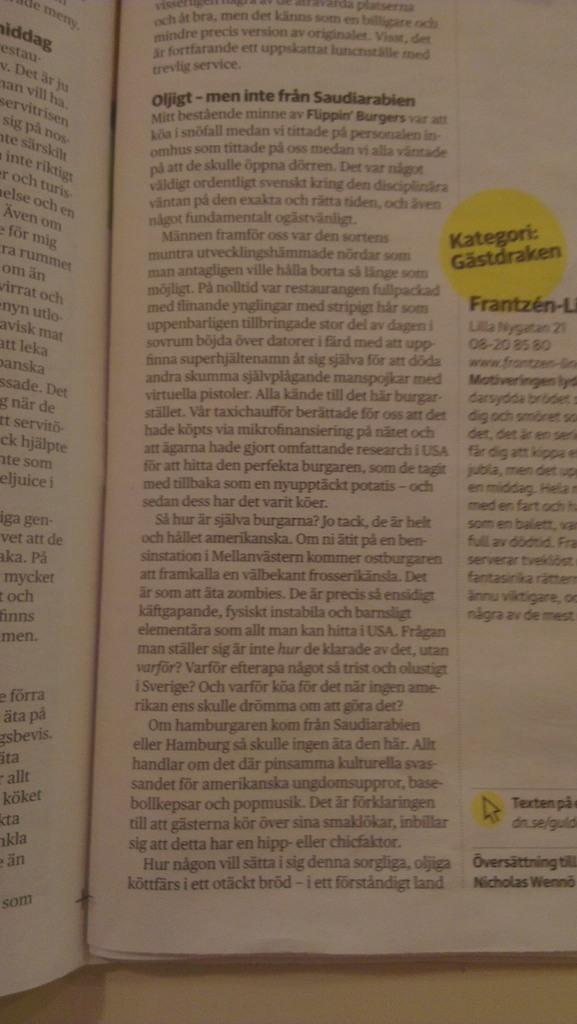<image>
Offer a succinct explanation of the picture presented. A BOOK IS OPENED TO A PAGE WITH A YELLOW STICKER THAT SAYS KATEGORI:GASTDRAKEN 